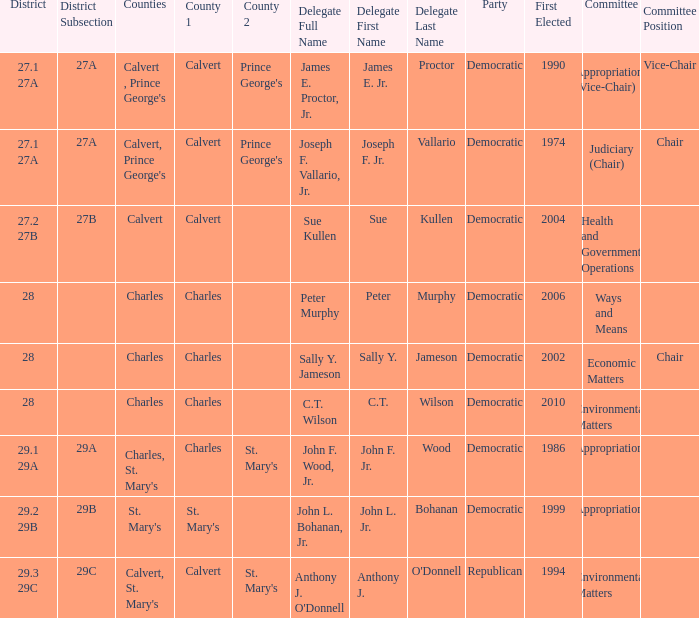When first elected was 2006, who was the delegate? Murphy, Peter Peter Murphy. 